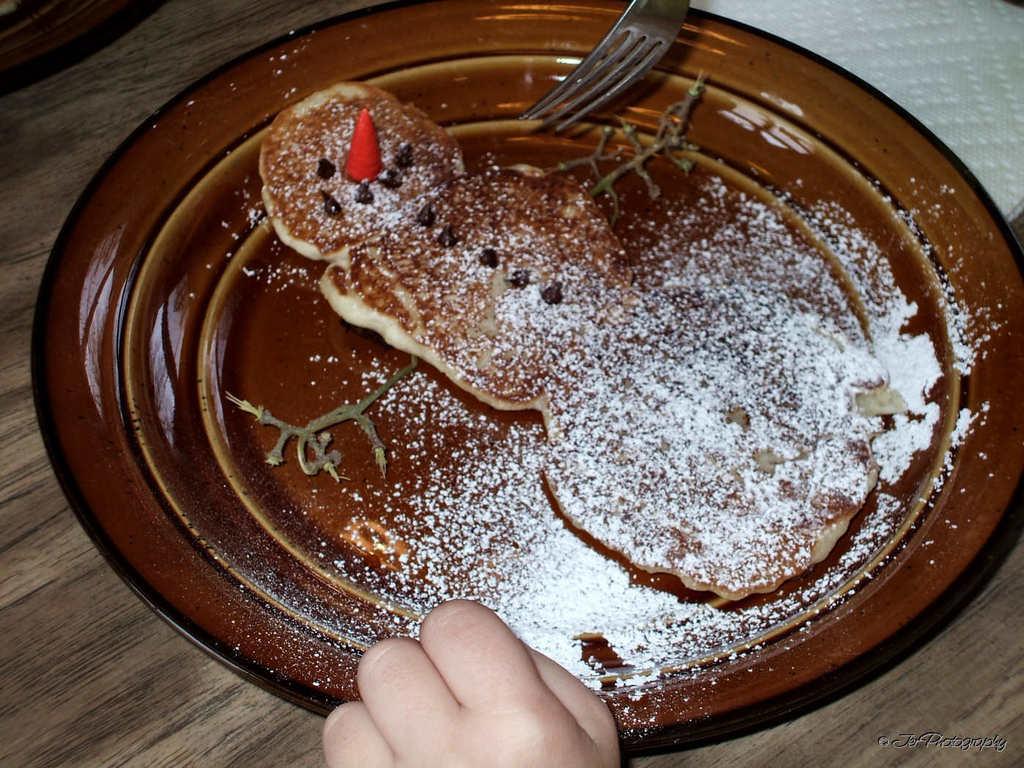Could you give a brief overview of what you see in this image? In this image we can see a plate on the surface. On the plate we can see the food. At the top we can see a fork and at the bottom we have a hand of a person. In the top right corner we can see a white object. In the top left corner we can see another object. 